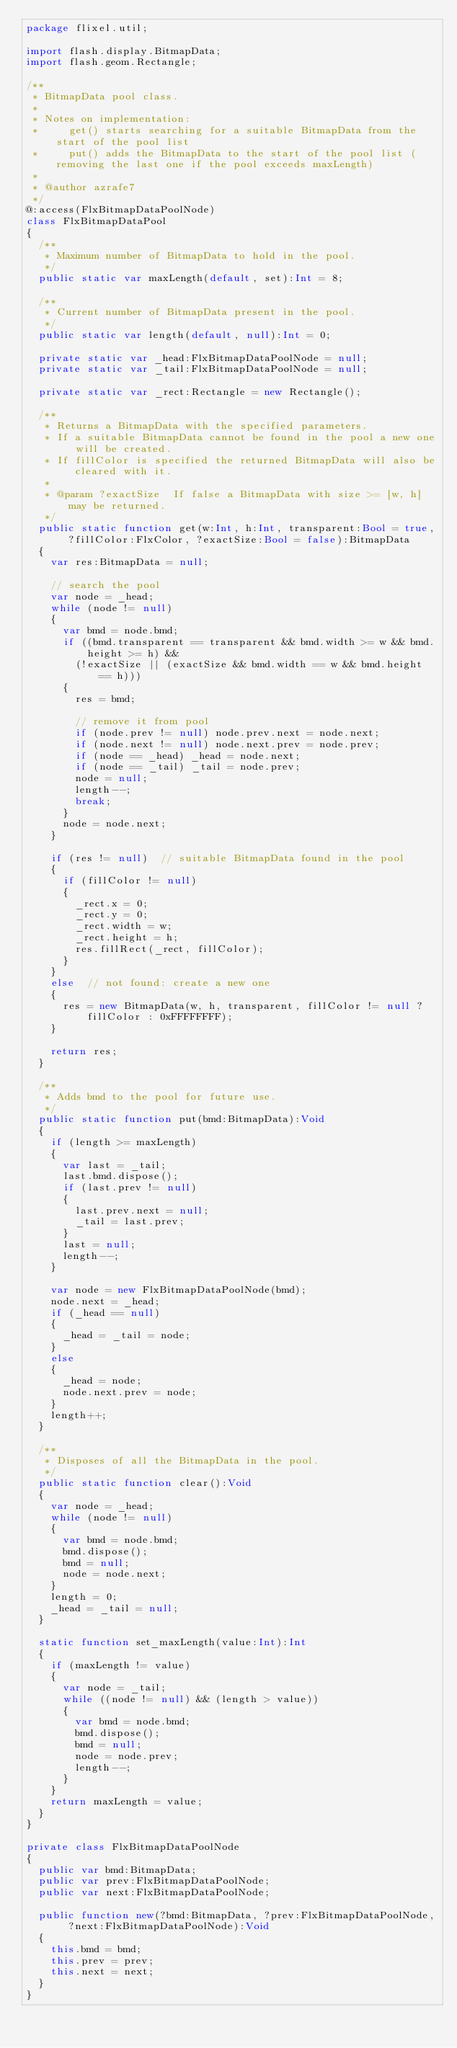<code> <loc_0><loc_0><loc_500><loc_500><_Haxe_>package flixel.util;

import flash.display.BitmapData;
import flash.geom.Rectangle;

/**
 * BitmapData pool class.
 * 
 * Notes on implementation:
 *     get() starts searching for a suitable BitmapData from the start of the pool list
 *     put() adds the BitmapData to the start of the pool list (removing the last one if the pool exceeds maxLength)
 * 
 * @author azrafe7
 */
@:access(FlxBitmapDataPoolNode)
class FlxBitmapDataPool
{
	/**
	 * Maximum number of BitmapData to hold in the pool. 
	 */
	public static var maxLength(default, set):Int = 8;
	
	/** 
	 * Current number of BitmapData present in the pool. 
	 */
	public static var length(default, null):Int = 0;
	
	private static var _head:FlxBitmapDataPoolNode = null;
	private static var _tail:FlxBitmapDataPoolNode = null;
	
	private static var _rect:Rectangle = new Rectangle();
	
	/** 
	 * Returns a BitmapData with the specified parameters. 
	 * If a suitable BitmapData cannot be found in the pool a new one will be created.
	 * If fillColor is specified the returned BitmapData will also be cleared with it.
	 * 
	 * @param ?exactSize	If false a BitmapData with size >= [w, h] may be returned.
	 */
	public static function get(w:Int, h:Int, transparent:Bool = true, ?fillColor:FlxColor, ?exactSize:Bool = false):BitmapData 
	{
		var res:BitmapData = null;
		
		// search the pool
		var node = _head;
		while (node != null) 
		{
			var bmd = node.bmd;
			if ((bmd.transparent == transparent && bmd.width >= w && bmd.height >= h) && 
				(!exactSize || (exactSize && bmd.width == w && bmd.height == h)))
			{
				res = bmd;
				
				// remove it from pool
				if (node.prev != null) node.prev.next = node.next;
				if (node.next != null) node.next.prev = node.prev;
				if (node == _head) _head = node.next;
				if (node == _tail) _tail = node.prev;
				node = null;
				length--;
				break;
			}
			node = node.next;
		}
		
		if (res != null) 	// suitable BitmapData found in the pool
		{
			if (fillColor != null) 
			{
				_rect.x = 0;
				_rect.y = 0;
				_rect.width = w;
				_rect.height = h;
				res.fillRect(_rect, fillColor);
			}
		} 
		else 	// not found: create a new one
		{
			res = new BitmapData(w, h, transparent, fillColor != null ? fillColor : 0xFFFFFFFF);
		}
		
		return res;
	}
	
	/** 
	 * Adds bmd to the pool for future use. 
	 */
	public static function put(bmd:BitmapData):Void 
	{
		if (length >= maxLength) 
		{
			var last = _tail;
			last.bmd.dispose();
			if (last.prev != null) 
			{
				last.prev.next = null;
				_tail = last.prev;
			}
			last = null;
			length--;
		}
		
		var node = new FlxBitmapDataPoolNode(bmd);
		node.next = _head;
		if (_head == null) 
		{
			_head = _tail = node;
		} 
		else 
		{
			_head = node;
			node.next.prev = node;
		}
		length++;
	}
	
	/**
	 * Disposes of all the BitmapData in the pool. 
	 */
	public static function clear():Void 
	{
		var node = _head;
		while (node != null) 
		{
			var bmd = node.bmd; 
			bmd.dispose();
			bmd = null;
			node = node.next;
		}
		length = 0;
		_head = _tail = null;
	}
	
	static function set_maxLength(value:Int):Int 
	{
		if (maxLength != value) 
		{
			var node = _tail;
			while ((node != null) && (length > value)) 
			{
				var bmd = node.bmd;
				bmd.dispose();
				bmd = null;
				node = node.prev;
				length--;
			}
		}
		return maxLength = value;
	}
}

private class FlxBitmapDataPoolNode 
{
	public var bmd:BitmapData;
	public var prev:FlxBitmapDataPoolNode;
	public var next:FlxBitmapDataPoolNode;
	
	public function new(?bmd:BitmapData, ?prev:FlxBitmapDataPoolNode, ?next:FlxBitmapDataPoolNode):Void 
	{
		this.bmd = bmd;
		this.prev = prev;
		this.next = next;
	}
}</code> 